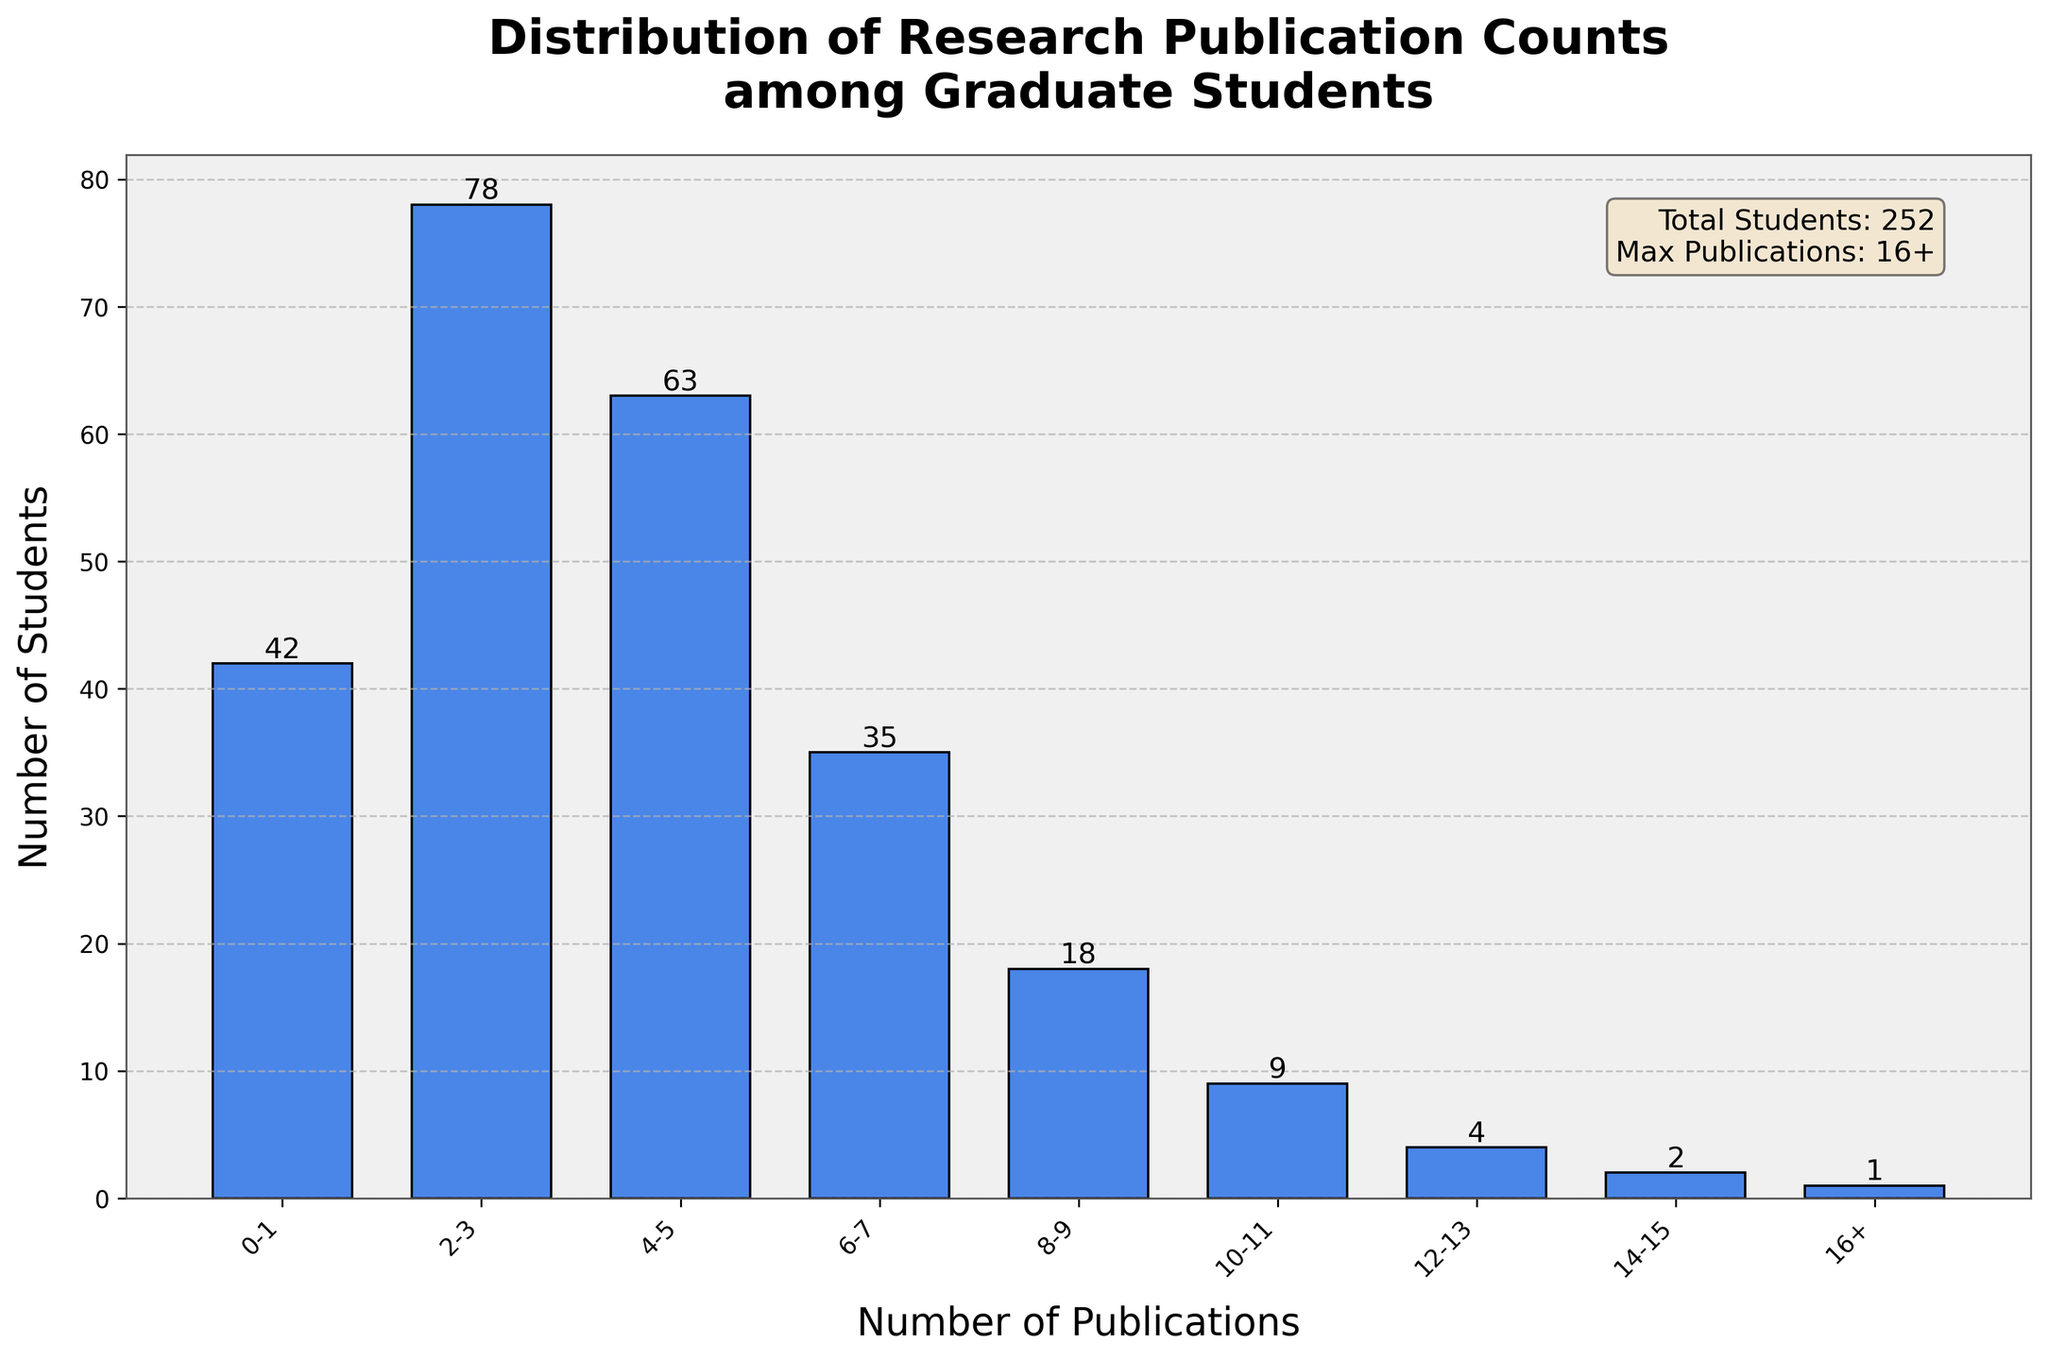What is the title of the histogram? The title is located at the top of the figure in large, bold text.
Answer: Distribution of Research Publication Counts among Graduate Students How many students have 6-7 publications? Locate the bar labeled "6-7" on the x-axis and read the number above the bar.
Answer: 35 What is the y-axis labeled as? The y-axis label is positioned vertically along the y-axis on the left side of the figure.
Answer: Number of Students How many publication count intervals are there? Count the number of distinct bars on the x-axis representing publication count intervals.
Answer: 9 Which publication count range has the highest number of students? Identify the tallest bar in the histogram and read its x-axis label.
Answer: 2-3 What is the total number of students displayed in the histogram? Refer to the additional information text box at the top right of the figure.
Answer: 252 How many students have more than 10 publications? Add the values of the bars representing 10-11, 12-13, 14-15, and 16+ publication counts.
Answer: 16 Compare the number of students with 4-5 publications to those with 8-9 publications. Which group is larger? Locate the bars for "4-5" and "8-9" and compare their heights; "4-5" has 63 and "8-9" has 18.
Answer: 4-5 What is the combined number of students with 0-1 and 2-3 publications? Add the numbers of students with 0-1 and 2-3 publications: 42 + 78.
Answer: 120 What is the average number of students per publication count interval? Divide the total number of students by the number of publication count intervals: 252 / 9.
Answer: 28 